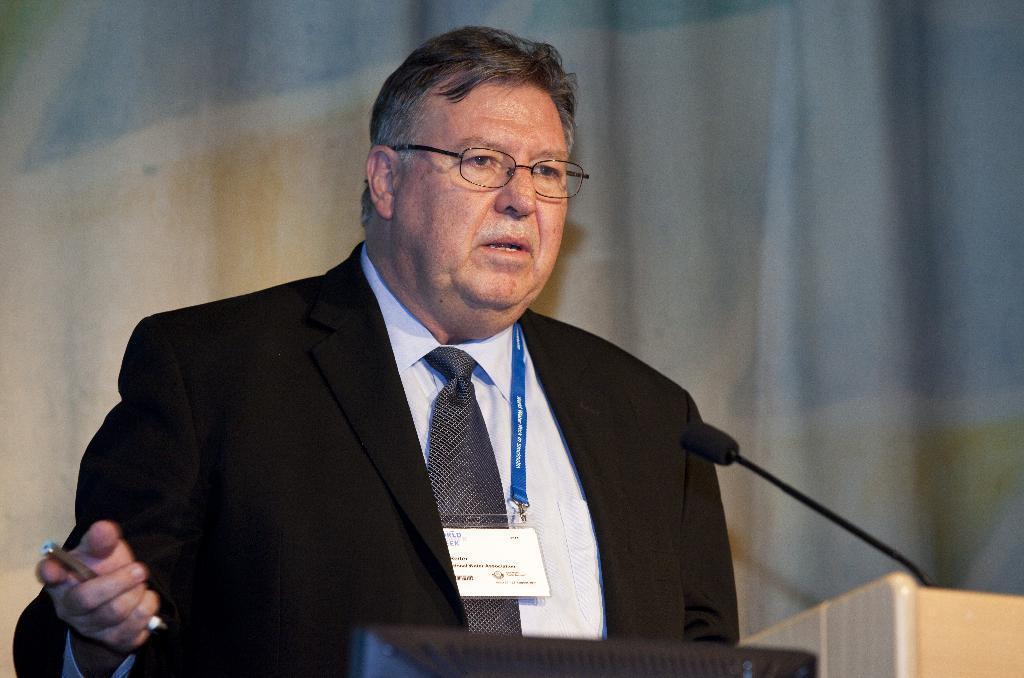Describe this image in one or two sentences. This picture seems to be clicked inside. In the center there is a person wearing black color suit, holding a pen and standing. On the right corner we can see the microphone. In the foreground there are some objects. In the background we can see the curtain. 